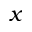<formula> <loc_0><loc_0><loc_500><loc_500>x</formula> 